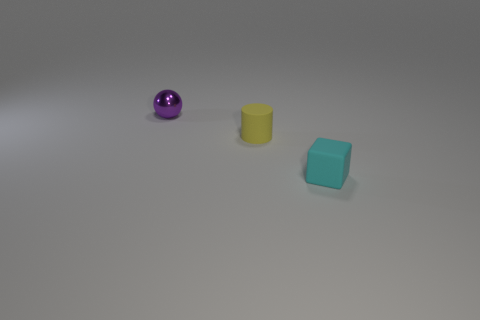Add 1 small purple metallic things. How many objects exist? 4 Subtract all spheres. How many objects are left? 2 Add 2 small yellow cylinders. How many small yellow cylinders are left? 3 Add 3 brown metallic cylinders. How many brown metallic cylinders exist? 3 Subtract 0 gray blocks. How many objects are left? 3 Subtract all red objects. Subtract all small yellow rubber objects. How many objects are left? 2 